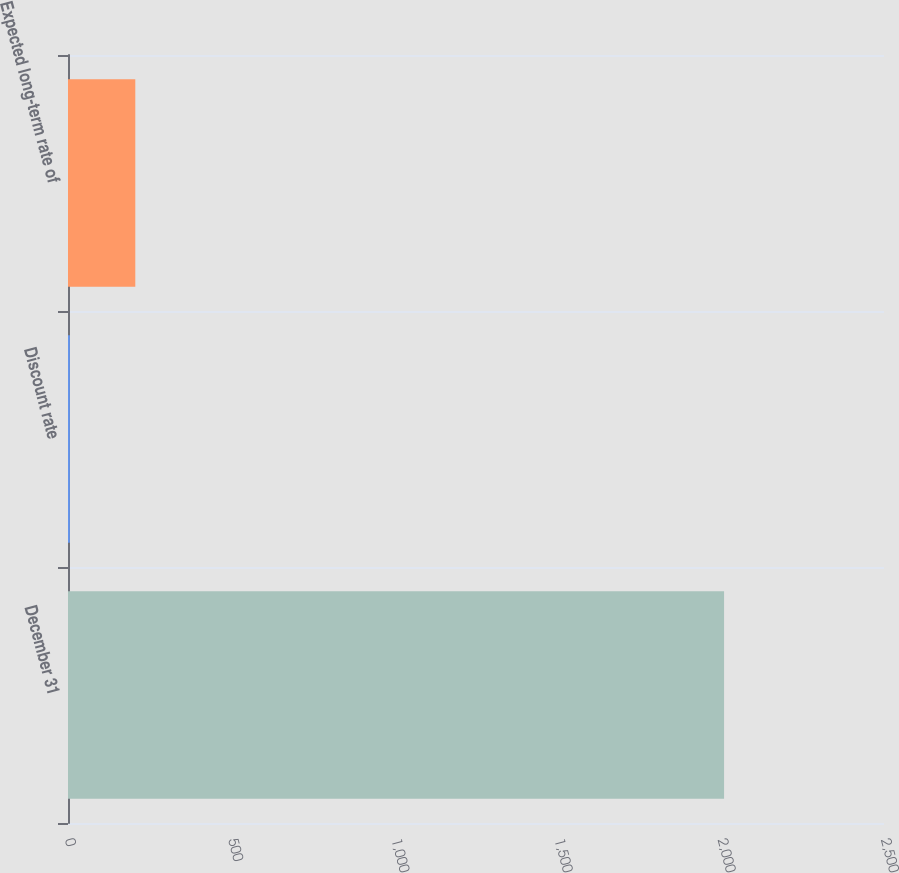Convert chart. <chart><loc_0><loc_0><loc_500><loc_500><bar_chart><fcel>December 31<fcel>Discount rate<fcel>Expected long-term rate of<nl><fcel>2010<fcel>5.75<fcel>206.18<nl></chart> 